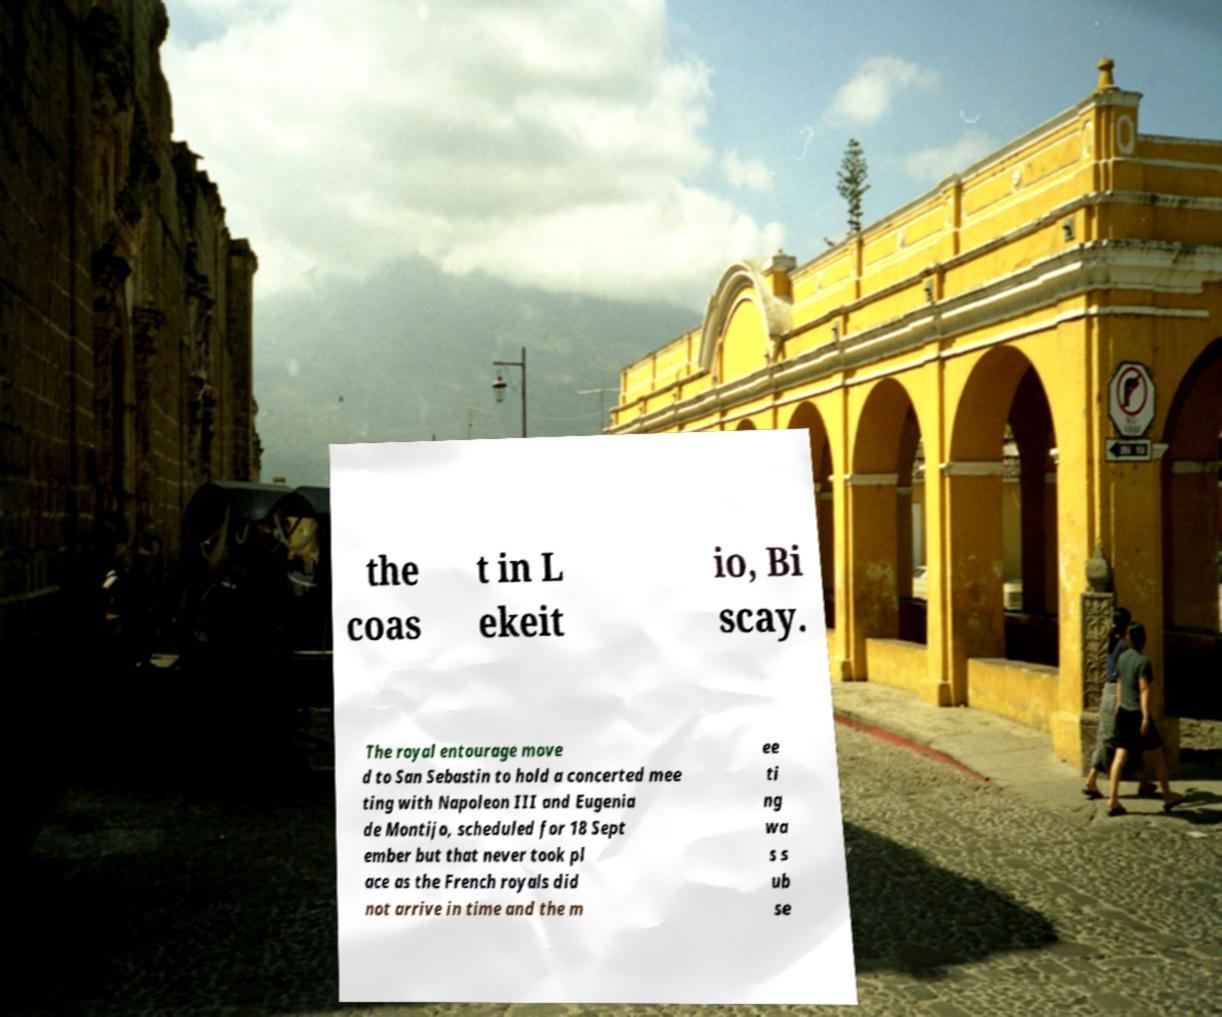Can you read and provide the text displayed in the image?This photo seems to have some interesting text. Can you extract and type it out for me? the coas t in L ekeit io, Bi scay. The royal entourage move d to San Sebastin to hold a concerted mee ting with Napoleon III and Eugenia de Montijo, scheduled for 18 Sept ember but that never took pl ace as the French royals did not arrive in time and the m ee ti ng wa s s ub se 